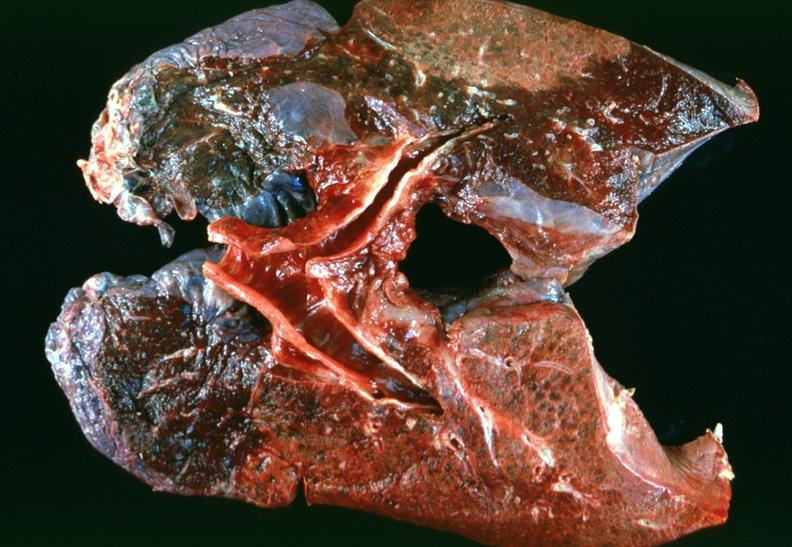s anomalous origin present?
Answer the question using a single word or phrase. No 